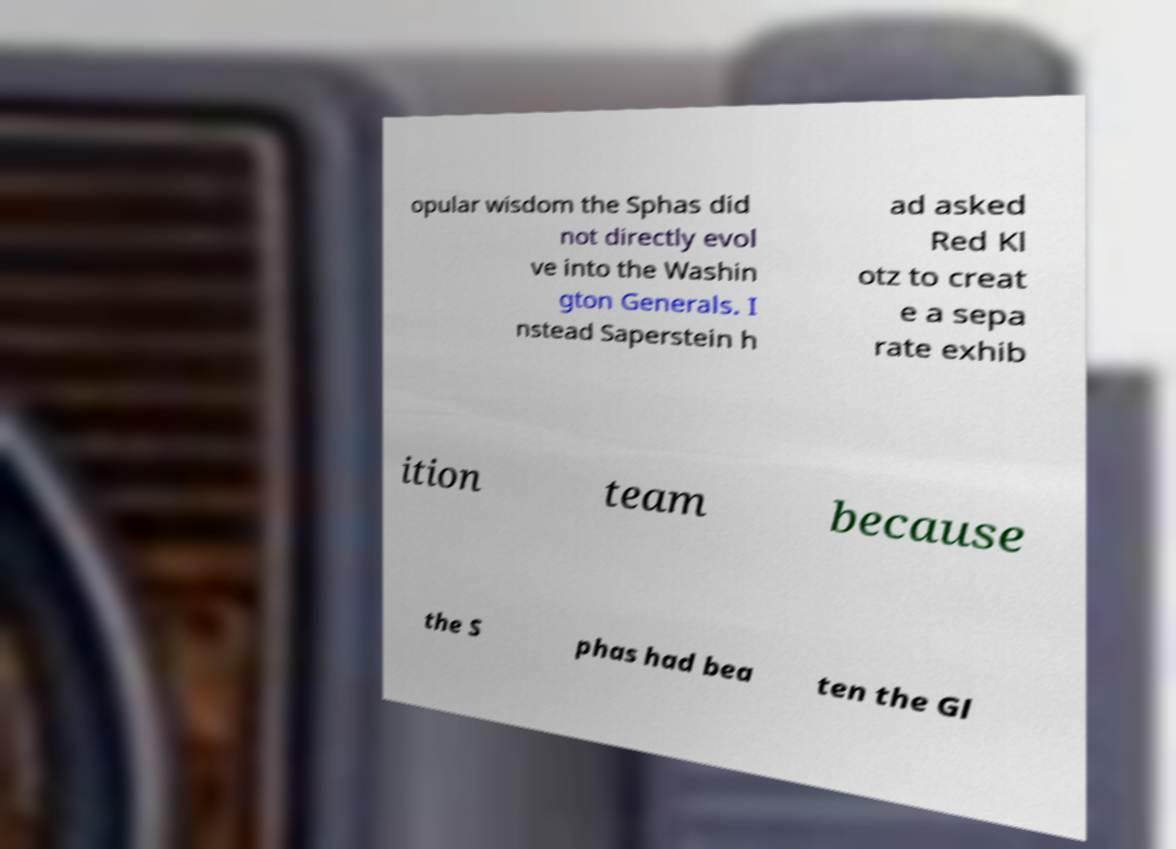There's text embedded in this image that I need extracted. Can you transcribe it verbatim? opular wisdom the Sphas did not directly evol ve into the Washin gton Generals. I nstead Saperstein h ad asked Red Kl otz to creat e a sepa rate exhib ition team because the S phas had bea ten the Gl 